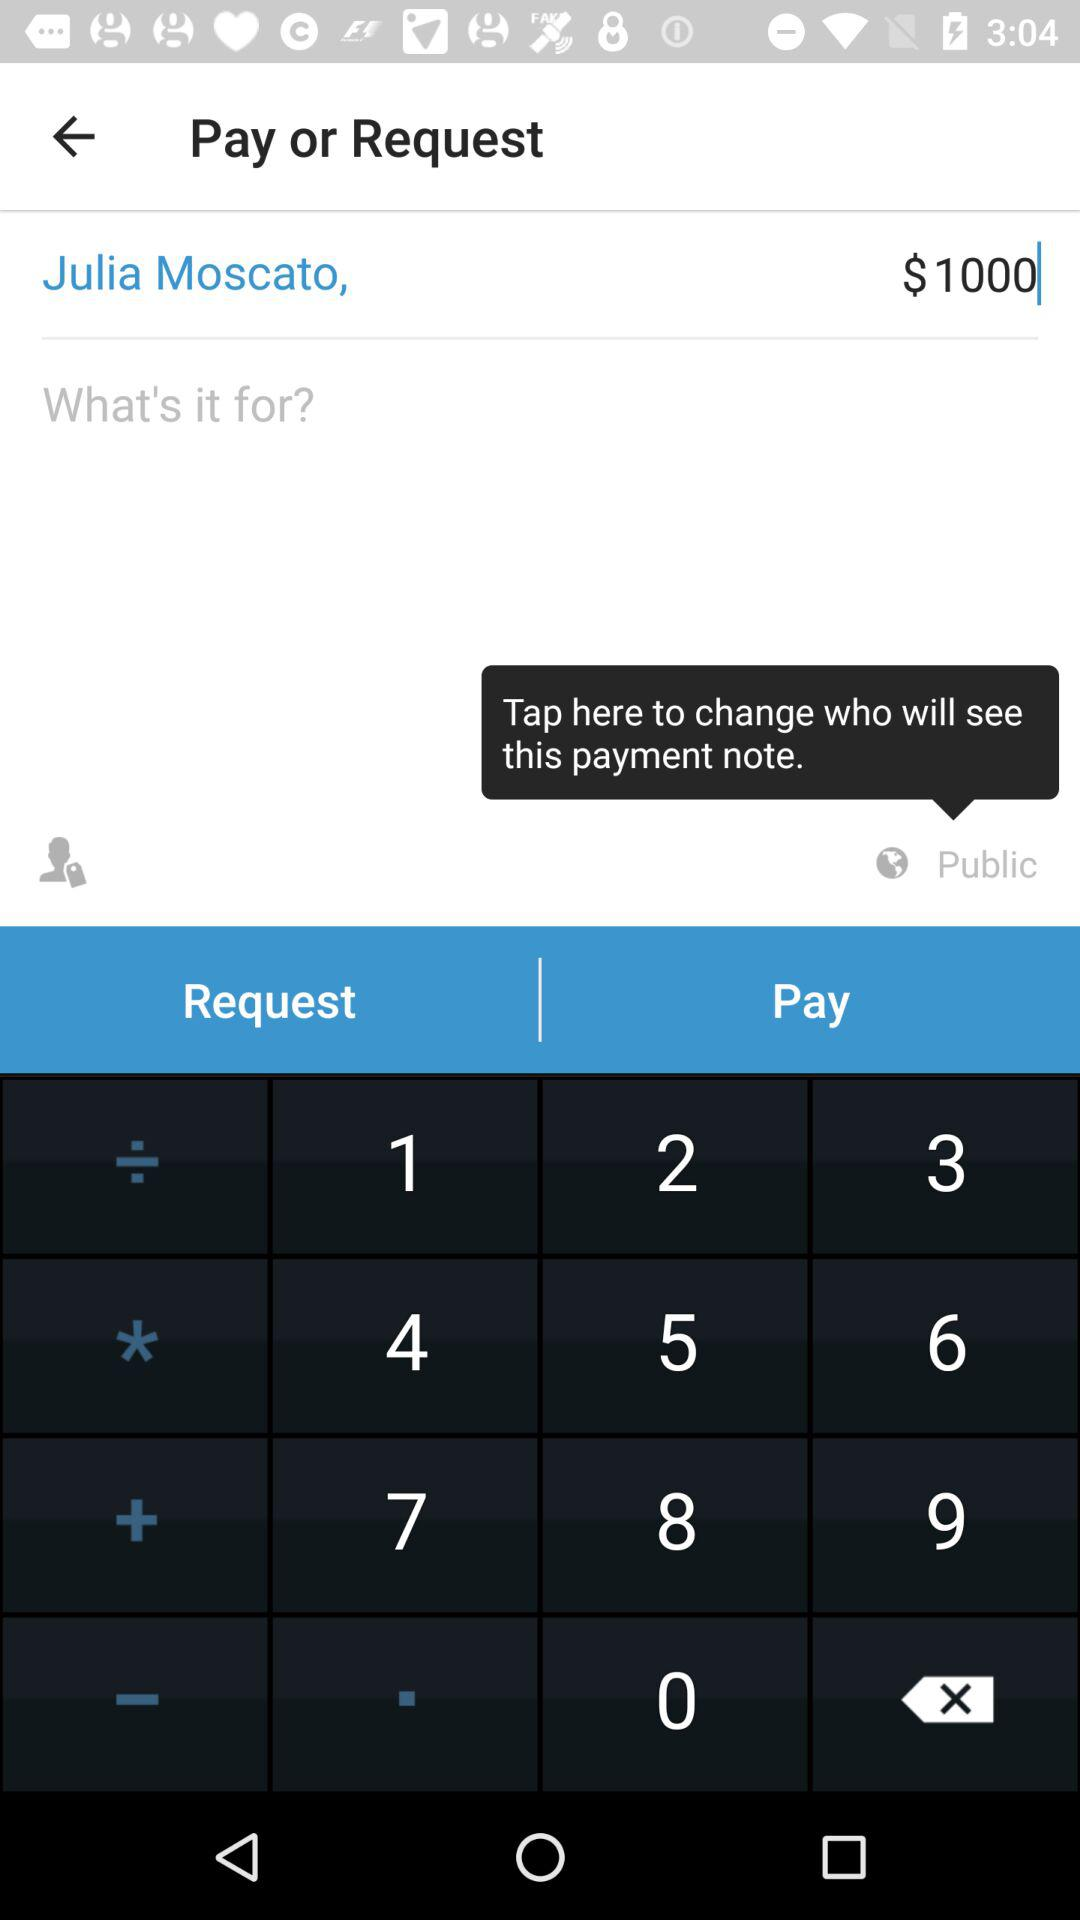What is the privacy setting for this payment note? The privacy setting is "Public". 